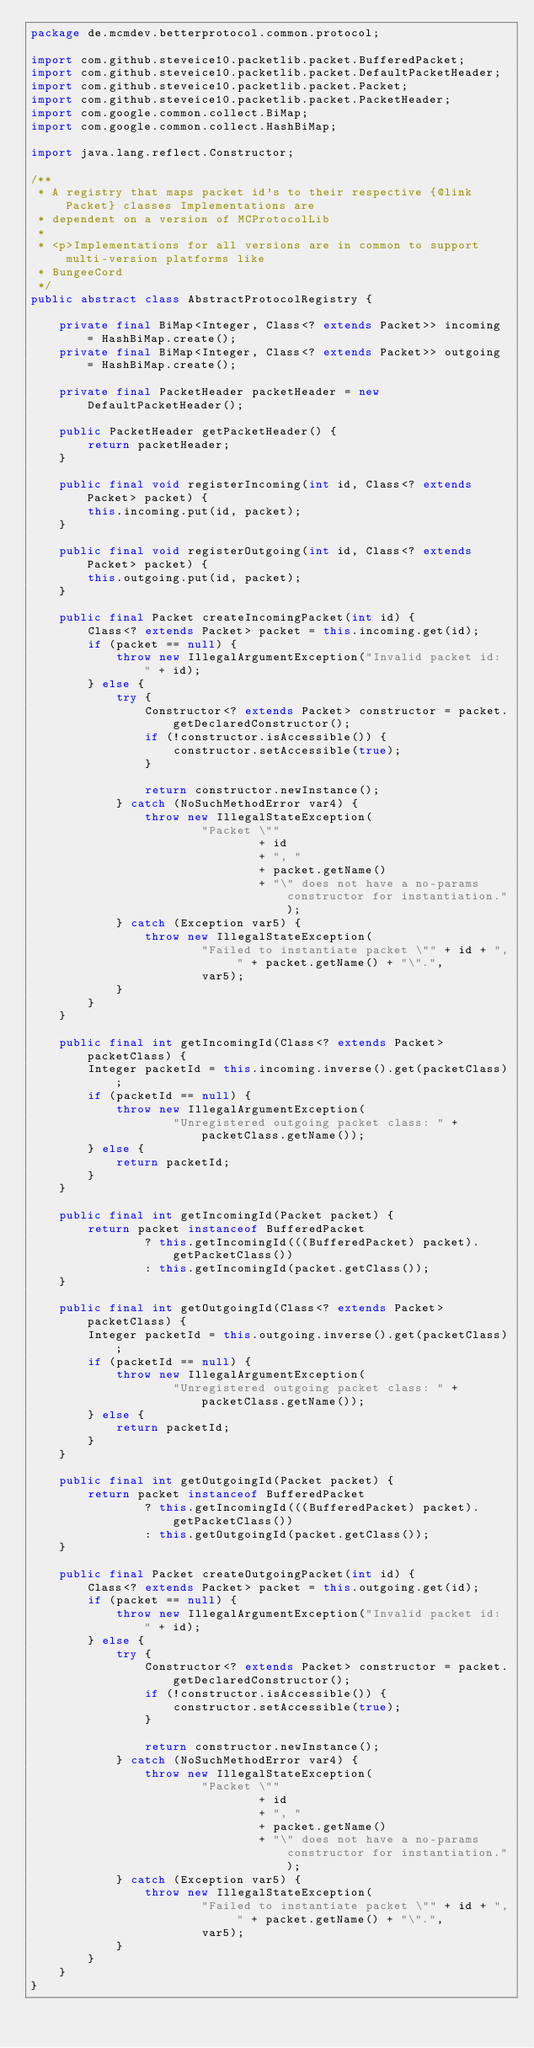Convert code to text. <code><loc_0><loc_0><loc_500><loc_500><_Java_>package de.mcmdev.betterprotocol.common.protocol;

import com.github.steveice10.packetlib.packet.BufferedPacket;
import com.github.steveice10.packetlib.packet.DefaultPacketHeader;
import com.github.steveice10.packetlib.packet.Packet;
import com.github.steveice10.packetlib.packet.PacketHeader;
import com.google.common.collect.BiMap;
import com.google.common.collect.HashBiMap;

import java.lang.reflect.Constructor;

/**
 * A registry that maps packet id's to their respective {@link Packet} classes Implementations are
 * dependent on a version of MCProtocolLib
 *
 * <p>Implementations for all versions are in common to support multi-version platforms like
 * BungeeCord
 */
public abstract class AbstractProtocolRegistry {

    private final BiMap<Integer, Class<? extends Packet>> incoming = HashBiMap.create();
    private final BiMap<Integer, Class<? extends Packet>> outgoing = HashBiMap.create();

    private final PacketHeader packetHeader = new DefaultPacketHeader();

    public PacketHeader getPacketHeader() {
        return packetHeader;
    }

    public final void registerIncoming(int id, Class<? extends Packet> packet) {
        this.incoming.put(id, packet);
    }

    public final void registerOutgoing(int id, Class<? extends Packet> packet) {
        this.outgoing.put(id, packet);
    }

    public final Packet createIncomingPacket(int id) {
        Class<? extends Packet> packet = this.incoming.get(id);
        if (packet == null) {
            throw new IllegalArgumentException("Invalid packet id: " + id);
        } else {
            try {
                Constructor<? extends Packet> constructor = packet.getDeclaredConstructor();
                if (!constructor.isAccessible()) {
                    constructor.setAccessible(true);
                }

                return constructor.newInstance();
            } catch (NoSuchMethodError var4) {
                throw new IllegalStateException(
                        "Packet \""
                                + id
                                + ", "
                                + packet.getName()
                                + "\" does not have a no-params constructor for instantiation.");
            } catch (Exception var5) {
                throw new IllegalStateException(
                        "Failed to instantiate packet \"" + id + ", " + packet.getName() + "\".",
                        var5);
            }
        }
    }

    public final int getIncomingId(Class<? extends Packet> packetClass) {
        Integer packetId = this.incoming.inverse().get(packetClass);
        if (packetId == null) {
            throw new IllegalArgumentException(
                    "Unregistered outgoing packet class: " + packetClass.getName());
        } else {
            return packetId;
        }
    }

    public final int getIncomingId(Packet packet) {
        return packet instanceof BufferedPacket
                ? this.getIncomingId(((BufferedPacket) packet).getPacketClass())
                : this.getIncomingId(packet.getClass());
    }

    public final int getOutgoingId(Class<? extends Packet> packetClass) {
        Integer packetId = this.outgoing.inverse().get(packetClass);
        if (packetId == null) {
            throw new IllegalArgumentException(
                    "Unregistered outgoing packet class: " + packetClass.getName());
        } else {
            return packetId;
        }
    }

    public final int getOutgoingId(Packet packet) {
        return packet instanceof BufferedPacket
                ? this.getIncomingId(((BufferedPacket) packet).getPacketClass())
                : this.getOutgoingId(packet.getClass());
    }

    public final Packet createOutgoingPacket(int id) {
        Class<? extends Packet> packet = this.outgoing.get(id);
        if (packet == null) {
            throw new IllegalArgumentException("Invalid packet id: " + id);
        } else {
            try {
                Constructor<? extends Packet> constructor = packet.getDeclaredConstructor();
                if (!constructor.isAccessible()) {
                    constructor.setAccessible(true);
                }

                return constructor.newInstance();
            } catch (NoSuchMethodError var4) {
                throw new IllegalStateException(
                        "Packet \""
                                + id
                                + ", "
                                + packet.getName()
                                + "\" does not have a no-params constructor for instantiation.");
            } catch (Exception var5) {
                throw new IllegalStateException(
                        "Failed to instantiate packet \"" + id + ", " + packet.getName() + "\".",
                        var5);
            }
        }
    }
}
</code> 